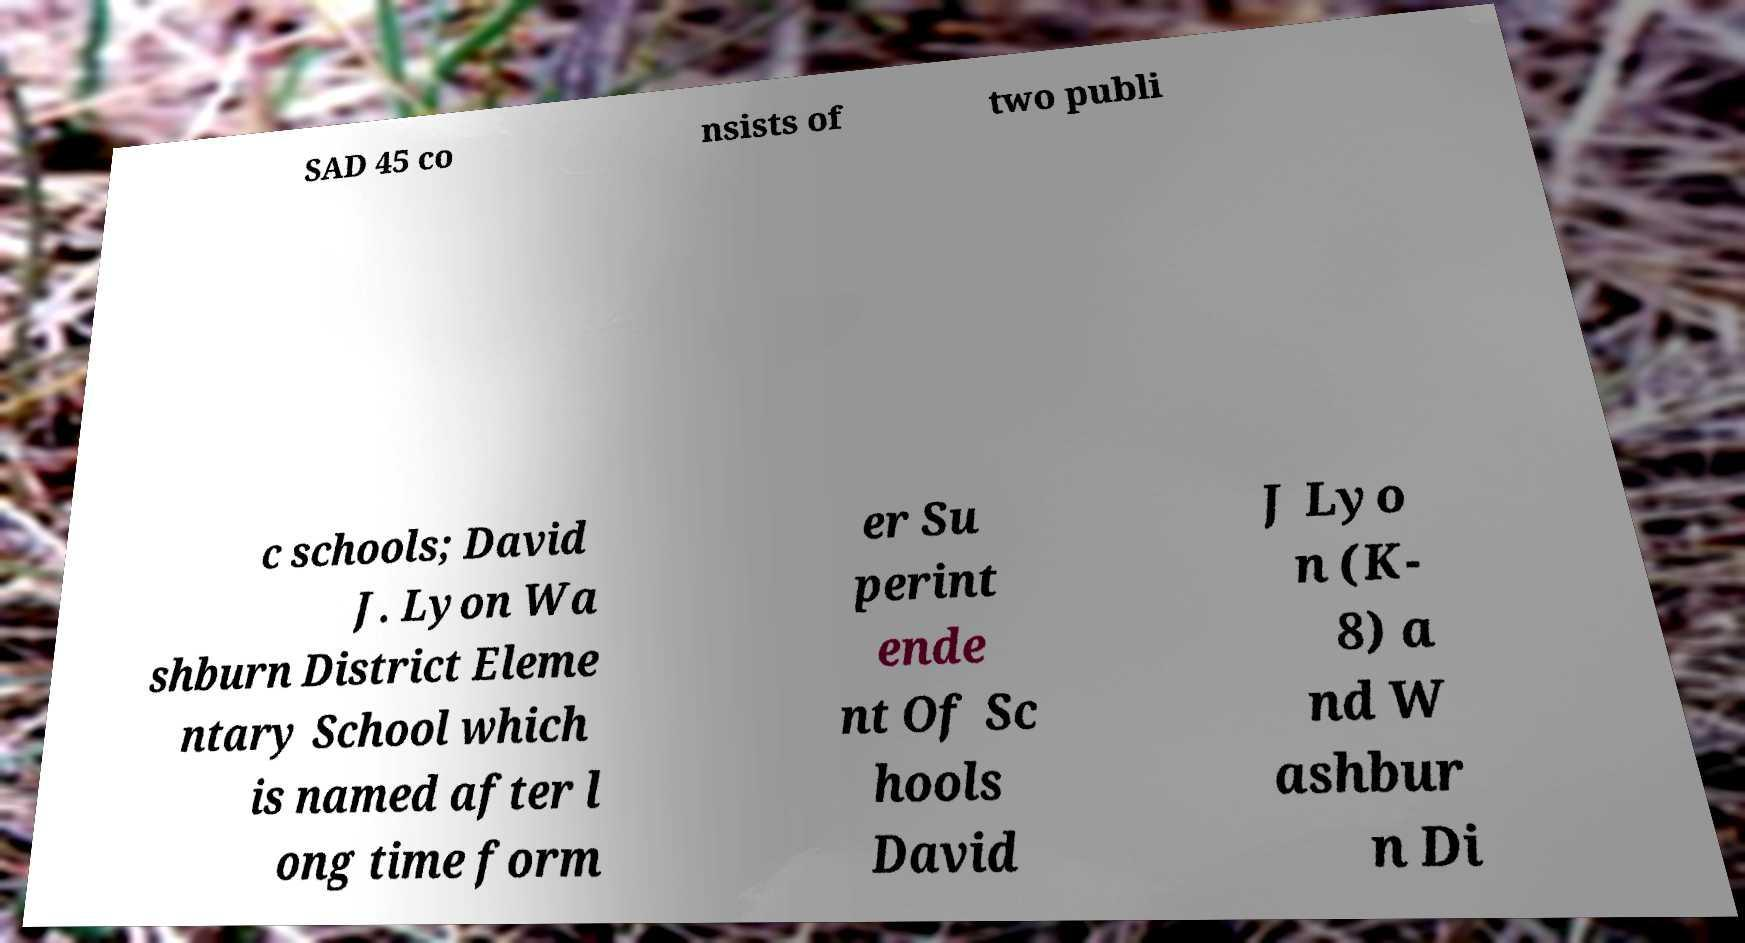Please read and relay the text visible in this image. What does it say? SAD 45 co nsists of two publi c schools; David J. Lyon Wa shburn District Eleme ntary School which is named after l ong time form er Su perint ende nt Of Sc hools David J Lyo n (K- 8) a nd W ashbur n Di 